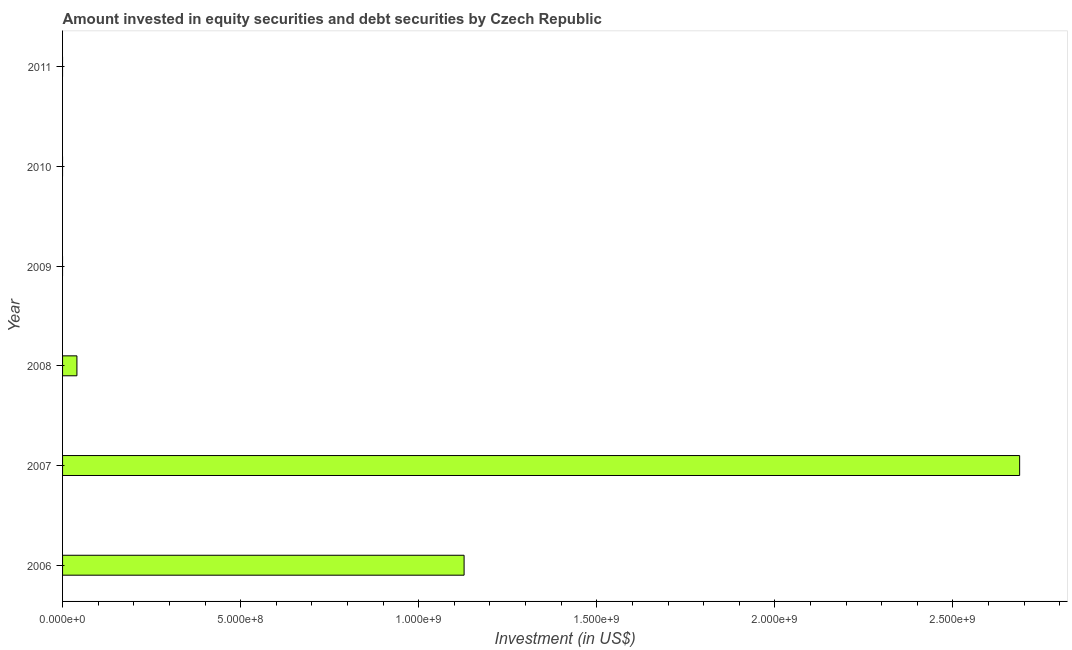Does the graph contain any zero values?
Provide a succinct answer. Yes. Does the graph contain grids?
Your answer should be very brief. No. What is the title of the graph?
Offer a very short reply. Amount invested in equity securities and debt securities by Czech Republic. What is the label or title of the X-axis?
Your answer should be very brief. Investment (in US$). What is the portfolio investment in 2007?
Give a very brief answer. 2.69e+09. Across all years, what is the maximum portfolio investment?
Offer a terse response. 2.69e+09. Across all years, what is the minimum portfolio investment?
Offer a very short reply. 0. What is the sum of the portfolio investment?
Your answer should be compact. 3.85e+09. What is the difference between the portfolio investment in 2007 and 2008?
Make the answer very short. 2.65e+09. What is the average portfolio investment per year?
Your answer should be compact. 6.42e+08. What is the median portfolio investment?
Make the answer very short. 2.02e+07. In how many years, is the portfolio investment greater than 2100000000 US$?
Make the answer very short. 1. What is the ratio of the portfolio investment in 2006 to that in 2007?
Keep it short and to the point. 0.42. Is the difference between the portfolio investment in 2006 and 2007 greater than the difference between any two years?
Your answer should be very brief. No. What is the difference between the highest and the second highest portfolio investment?
Offer a terse response. 1.56e+09. What is the difference between the highest and the lowest portfolio investment?
Your response must be concise. 2.69e+09. In how many years, is the portfolio investment greater than the average portfolio investment taken over all years?
Provide a succinct answer. 2. How many years are there in the graph?
Your response must be concise. 6. What is the Investment (in US$) of 2006?
Your answer should be very brief. 1.13e+09. What is the Investment (in US$) of 2007?
Offer a very short reply. 2.69e+09. What is the Investment (in US$) of 2008?
Provide a short and direct response. 4.03e+07. What is the Investment (in US$) of 2010?
Provide a short and direct response. 0. What is the difference between the Investment (in US$) in 2006 and 2007?
Offer a terse response. -1.56e+09. What is the difference between the Investment (in US$) in 2006 and 2008?
Make the answer very short. 1.09e+09. What is the difference between the Investment (in US$) in 2007 and 2008?
Keep it short and to the point. 2.65e+09. What is the ratio of the Investment (in US$) in 2006 to that in 2007?
Keep it short and to the point. 0.42. What is the ratio of the Investment (in US$) in 2006 to that in 2008?
Give a very brief answer. 27.96. What is the ratio of the Investment (in US$) in 2007 to that in 2008?
Your answer should be compact. 66.65. 